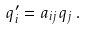Convert formula to latex. <formula><loc_0><loc_0><loc_500><loc_500>q _ { i } ^ { \prime } = a _ { i j } q _ { j } \, .</formula> 